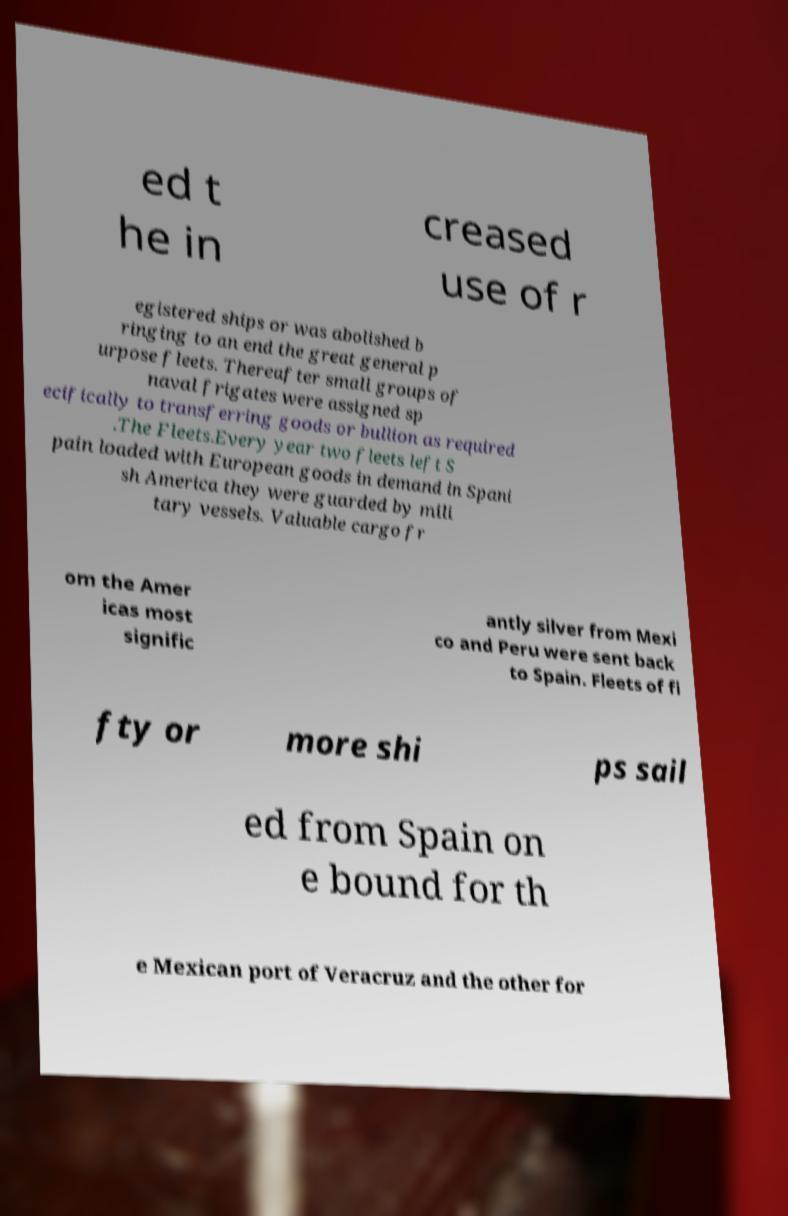Please read and relay the text visible in this image. What does it say? ed t he in creased use of r egistered ships or was abolished b ringing to an end the great general p urpose fleets. Thereafter small groups of naval frigates were assigned sp ecifically to transferring goods or bullion as required .The Fleets.Every year two fleets left S pain loaded with European goods in demand in Spani sh America they were guarded by mili tary vessels. Valuable cargo fr om the Amer icas most signific antly silver from Mexi co and Peru were sent back to Spain. Fleets of fi fty or more shi ps sail ed from Spain on e bound for th e Mexican port of Veracruz and the other for 